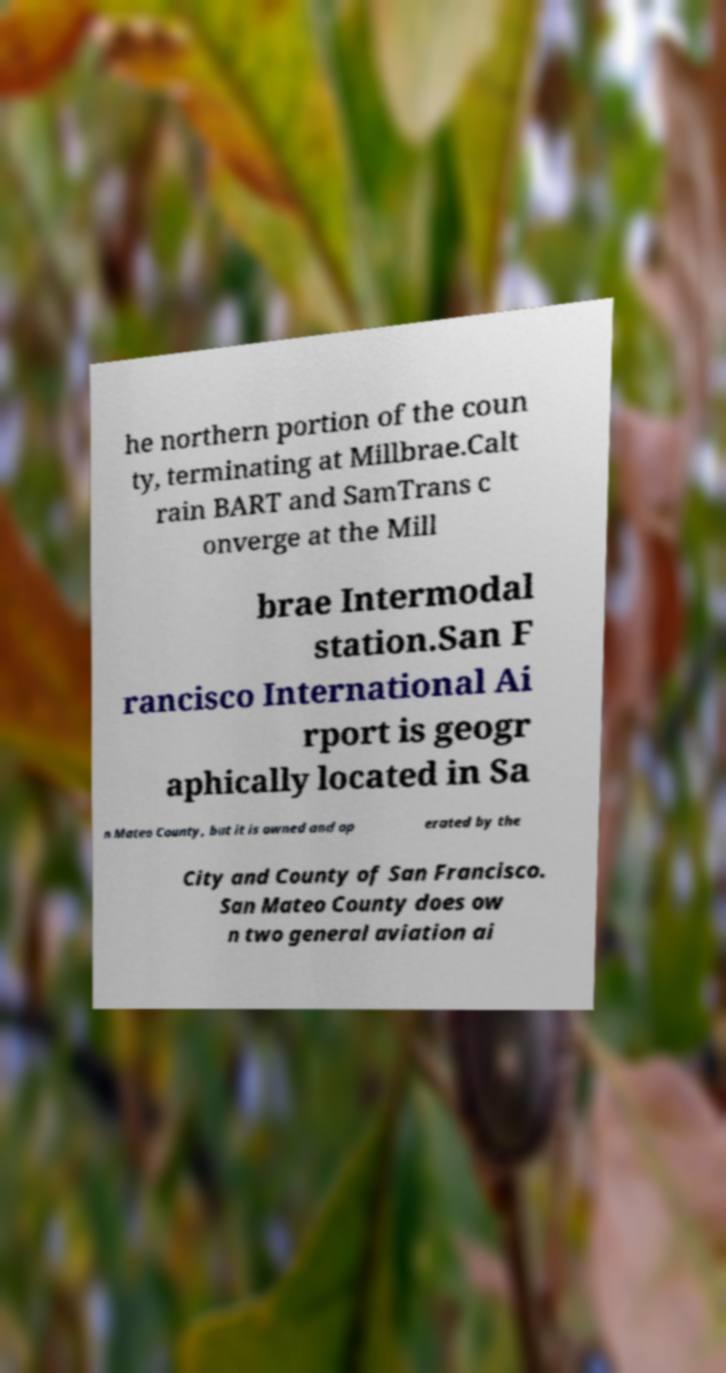Could you assist in decoding the text presented in this image and type it out clearly? he northern portion of the coun ty, terminating at Millbrae.Calt rain BART and SamTrans c onverge at the Mill brae Intermodal station.San F rancisco International Ai rport is geogr aphically located in Sa n Mateo County, but it is owned and op erated by the City and County of San Francisco. San Mateo County does ow n two general aviation ai 